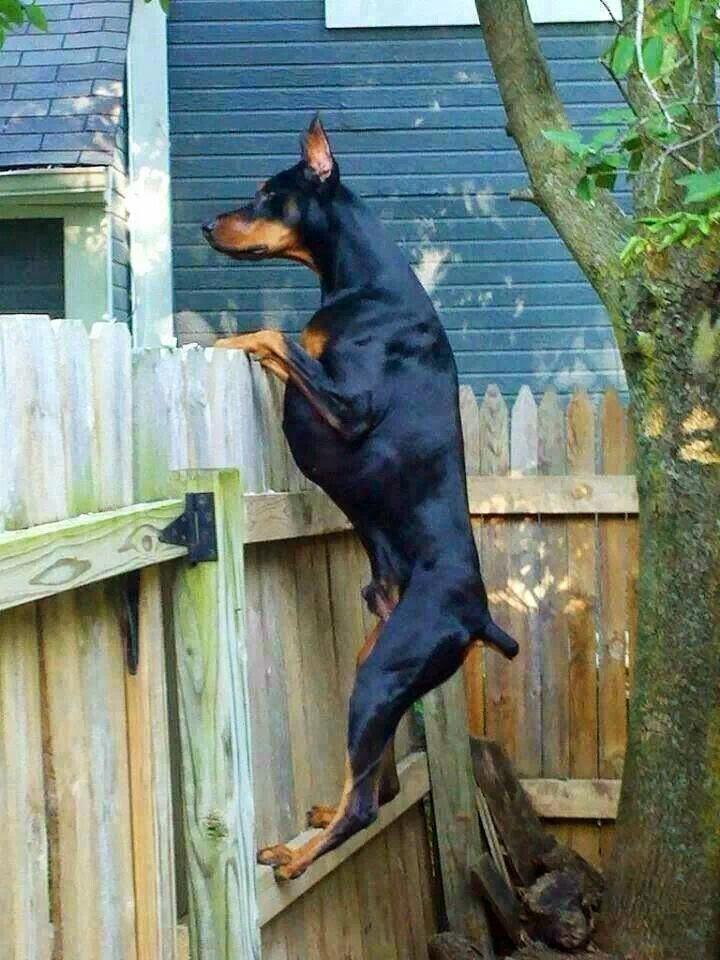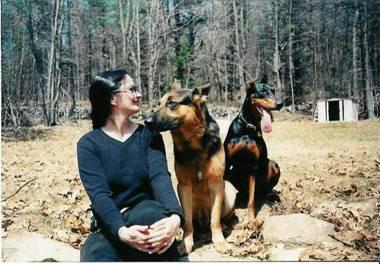The first image is the image on the left, the second image is the image on the right. Analyze the images presented: Is the assertion "One image features a doberman with its front paws over the edge of a wooden fence." valid? Answer yes or no. Yes. The first image is the image on the left, the second image is the image on the right. Evaluate the accuracy of this statement regarding the images: "One doberman has its front paws on a fence.". Is it true? Answer yes or no. Yes. 